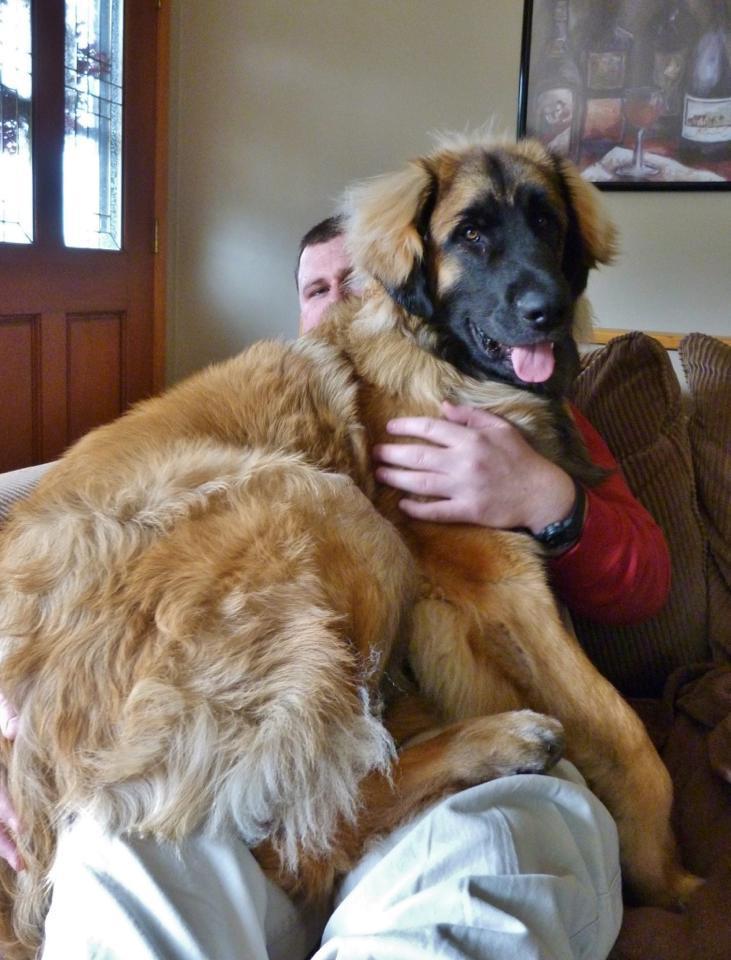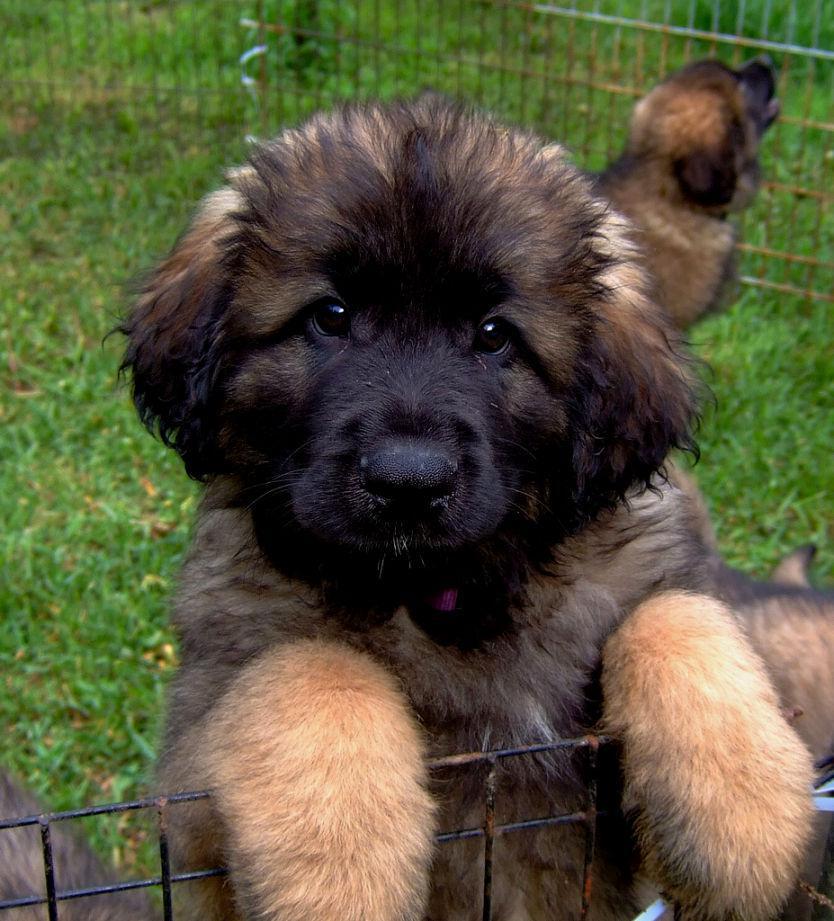The first image is the image on the left, the second image is the image on the right. Considering the images on both sides, is "Both dogs are outside on the grass." valid? Answer yes or no. No. The first image is the image on the left, the second image is the image on the right. Assess this claim about the two images: "Right image shows one furry dog in an outdoor area enclosed by wire.". Correct or not? Answer yes or no. Yes. 